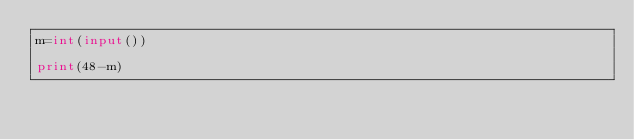Convert code to text. <code><loc_0><loc_0><loc_500><loc_500><_Python_>m=int(input())

print(48-m)</code> 